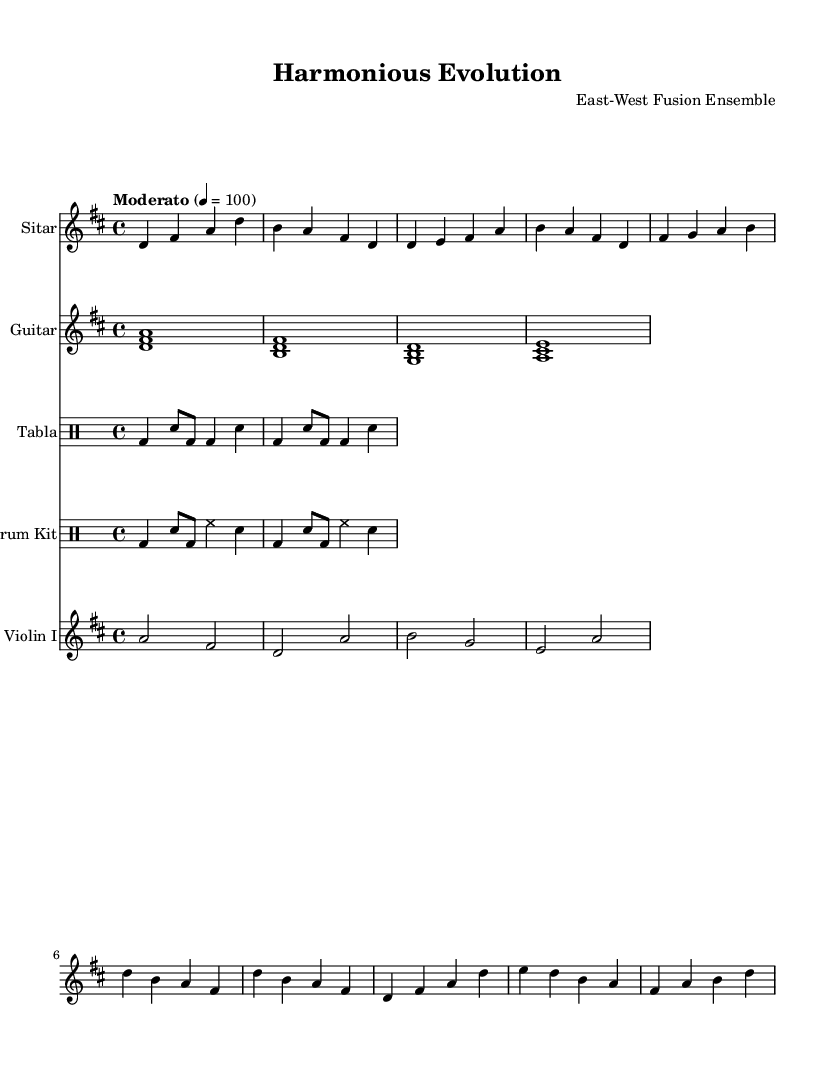What is the key signature of this music? The key signature indicates that there are two sharps, which correspond to F# and C#. This identifies the music as being in D major.
Answer: D major What is the time signature of this music? The time signature is indicated at the beginning as 4/4, which means there are four beats per measure and the quarter note receives one beat.
Answer: 4/4 What is the tempo marking for this piece? The tempo marking is "Moderato" with a metronome marking of 100 beats per minute, indicating a moderate pace for the piece.
Answer: Moderato 100 How many measures does the sitar part have? The sitar part consists of six distinct measures, as indicated by the vertical lines separating the sections of music.
Answer: Six measures What instruments are featured in this composition? The composition features five instruments: Sitar, Guitar, Tabla, Drum Kit, and Violin. This blend showcases a fusion of Eastern and Western musical elements.
Answer: Sitar, Guitar, Tabla, Drum Kit, Violin Which measure does the first high note occur for the violin? The first high note in the violin part occurs in measure 2 where the note D is played at a higher octave. This shows the range of the violin and its expressive capability.
Answer: Measure 2 How does the use of tabla and drum kit affect the piece's style? The tabla provides a traditional Eastern rhythmic foundation, while the drum kit introduces a contemporary syncopation, creating a bridge between traditional and modern styles in fusion music.
Answer: Traditional and contemporary 